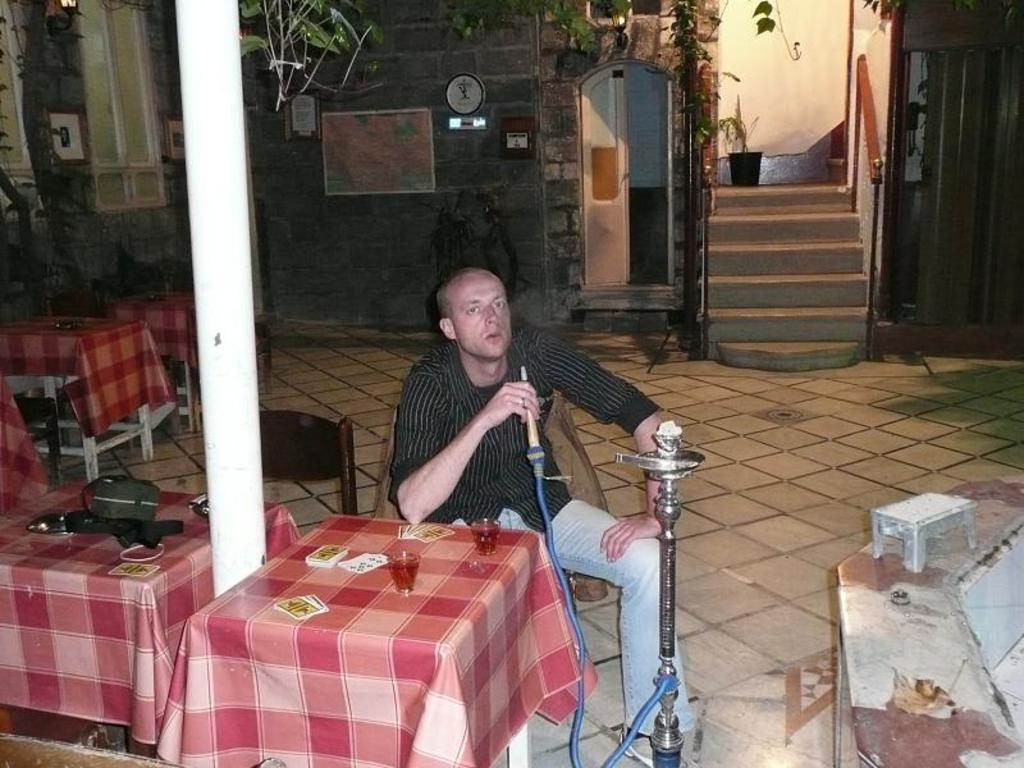Describe this image in one or two sentences. This image consists of a man holding a hookah pipe. In the front, there are tables covered with the clothes. On which there are wine glasses and playing cards. On the right, we can see a small stool. In the background, we can see a wall clock on the wall. On the left, there are windows. 